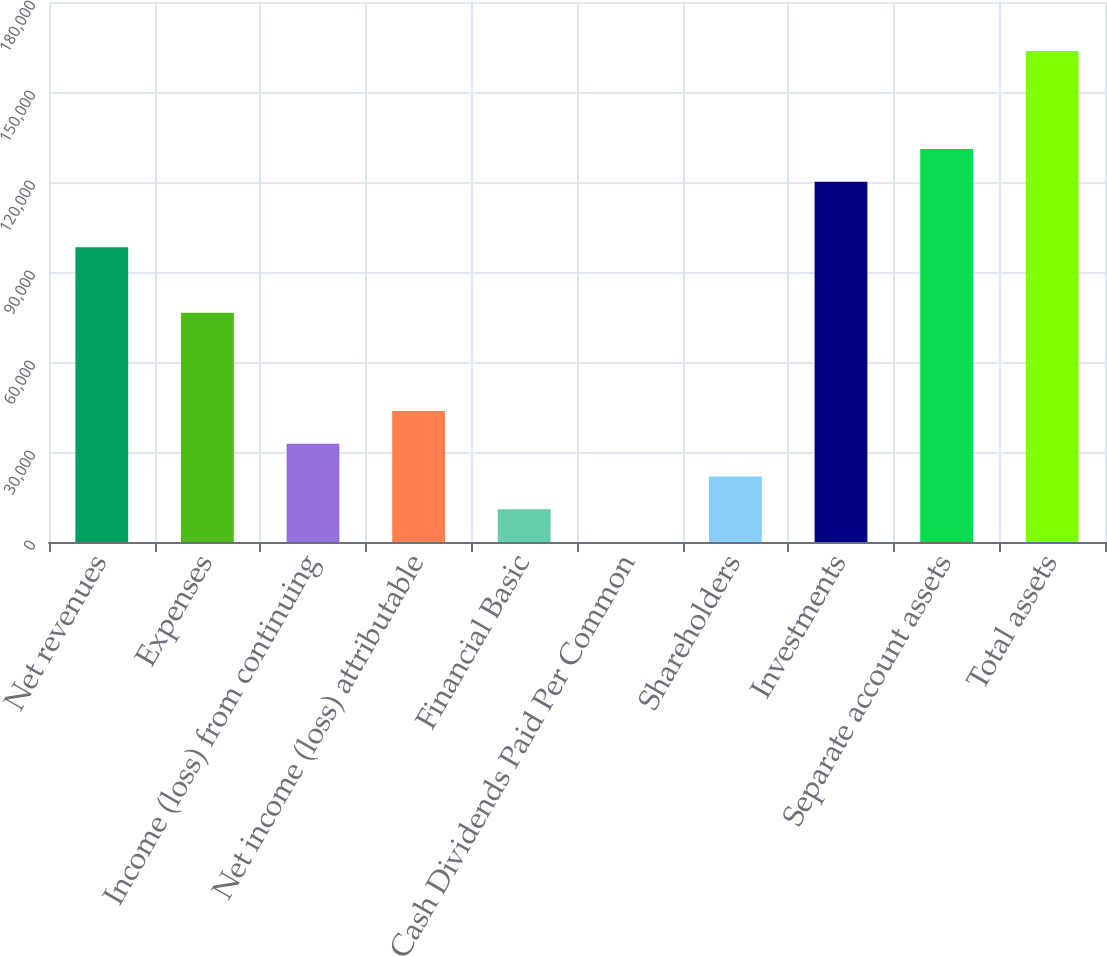Convert chart to OTSL. <chart><loc_0><loc_0><loc_500><loc_500><bar_chart><fcel>Net revenues<fcel>Expenses<fcel>Income (loss) from continuing<fcel>Net income (loss) attributable<fcel>Financial Basic<fcel>Cash Dividends Paid Per Common<fcel>Shareholders<fcel>Investments<fcel>Separate account assets<fcel>Total assets<nl><fcel>98221.5<fcel>76394.6<fcel>32740.9<fcel>43654.3<fcel>10914<fcel>0.56<fcel>21827.4<fcel>120048<fcel>130962<fcel>163702<nl></chart> 